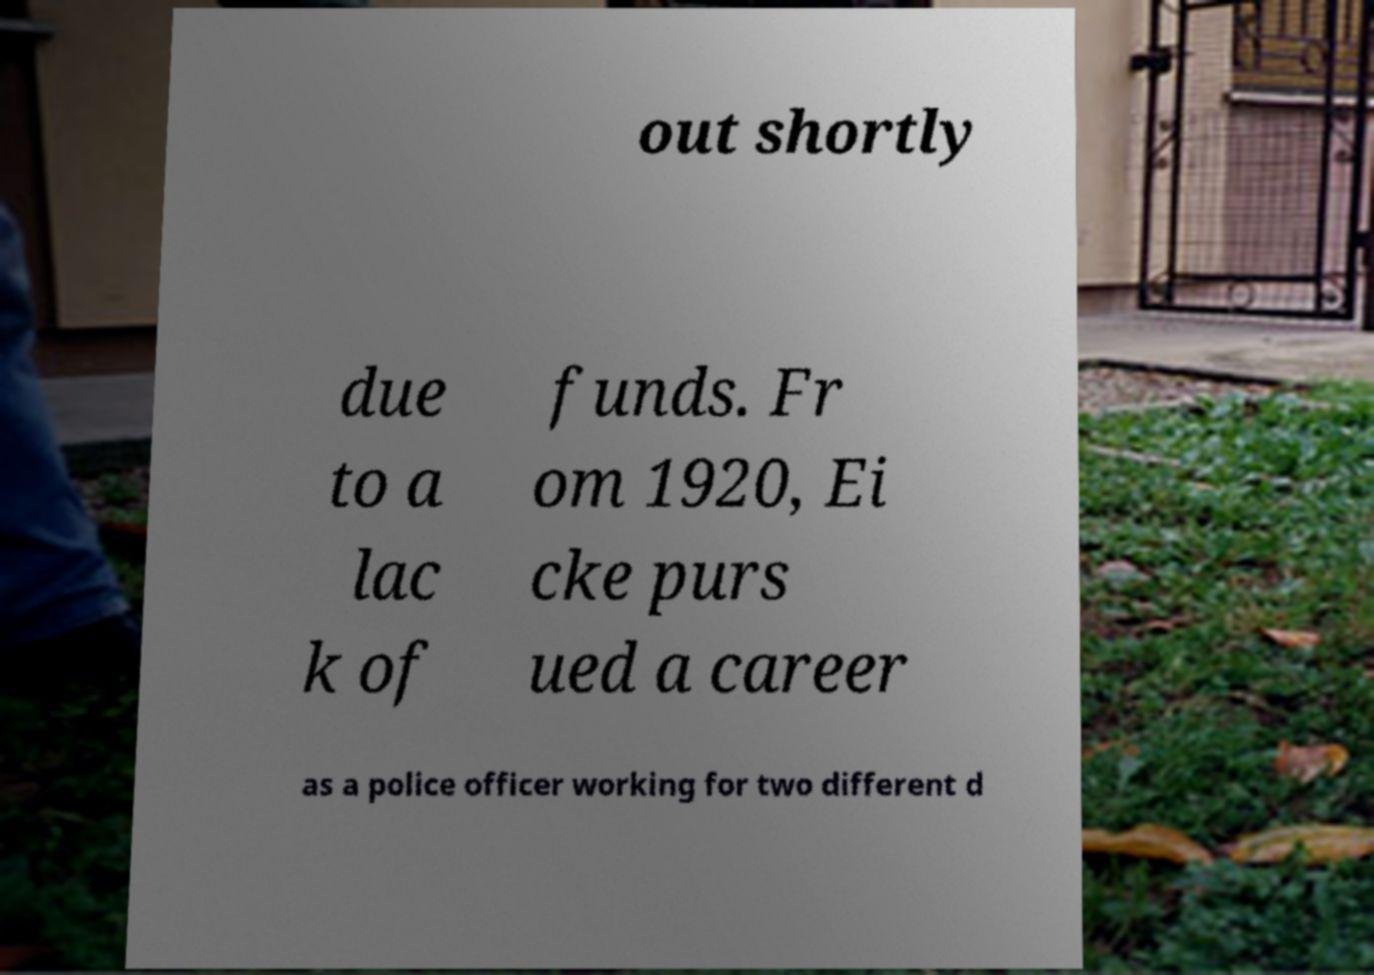Can you read and provide the text displayed in the image?This photo seems to have some interesting text. Can you extract and type it out for me? out shortly due to a lac k of funds. Fr om 1920, Ei cke purs ued a career as a police officer working for two different d 